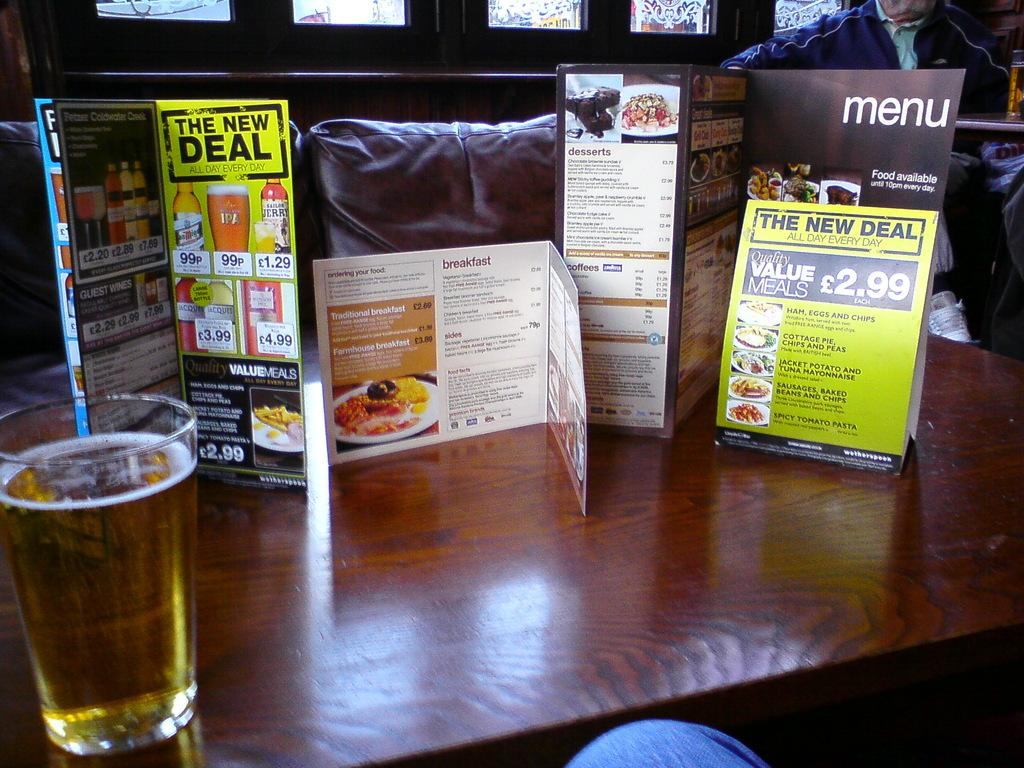What is located in the center of the image? There is a table in the middle of the image. What can be found on the table? Menu cards are present on the table. What type of container is on the table? A glass is placed on the table. How many rabbits can be seen in the scene? There are no rabbits present in the image; it only features a table with menu cards and a glass. What type of toad is sitting on the table in the image? There is no toad present in the image; it only features a table with menu cards and a glass. 